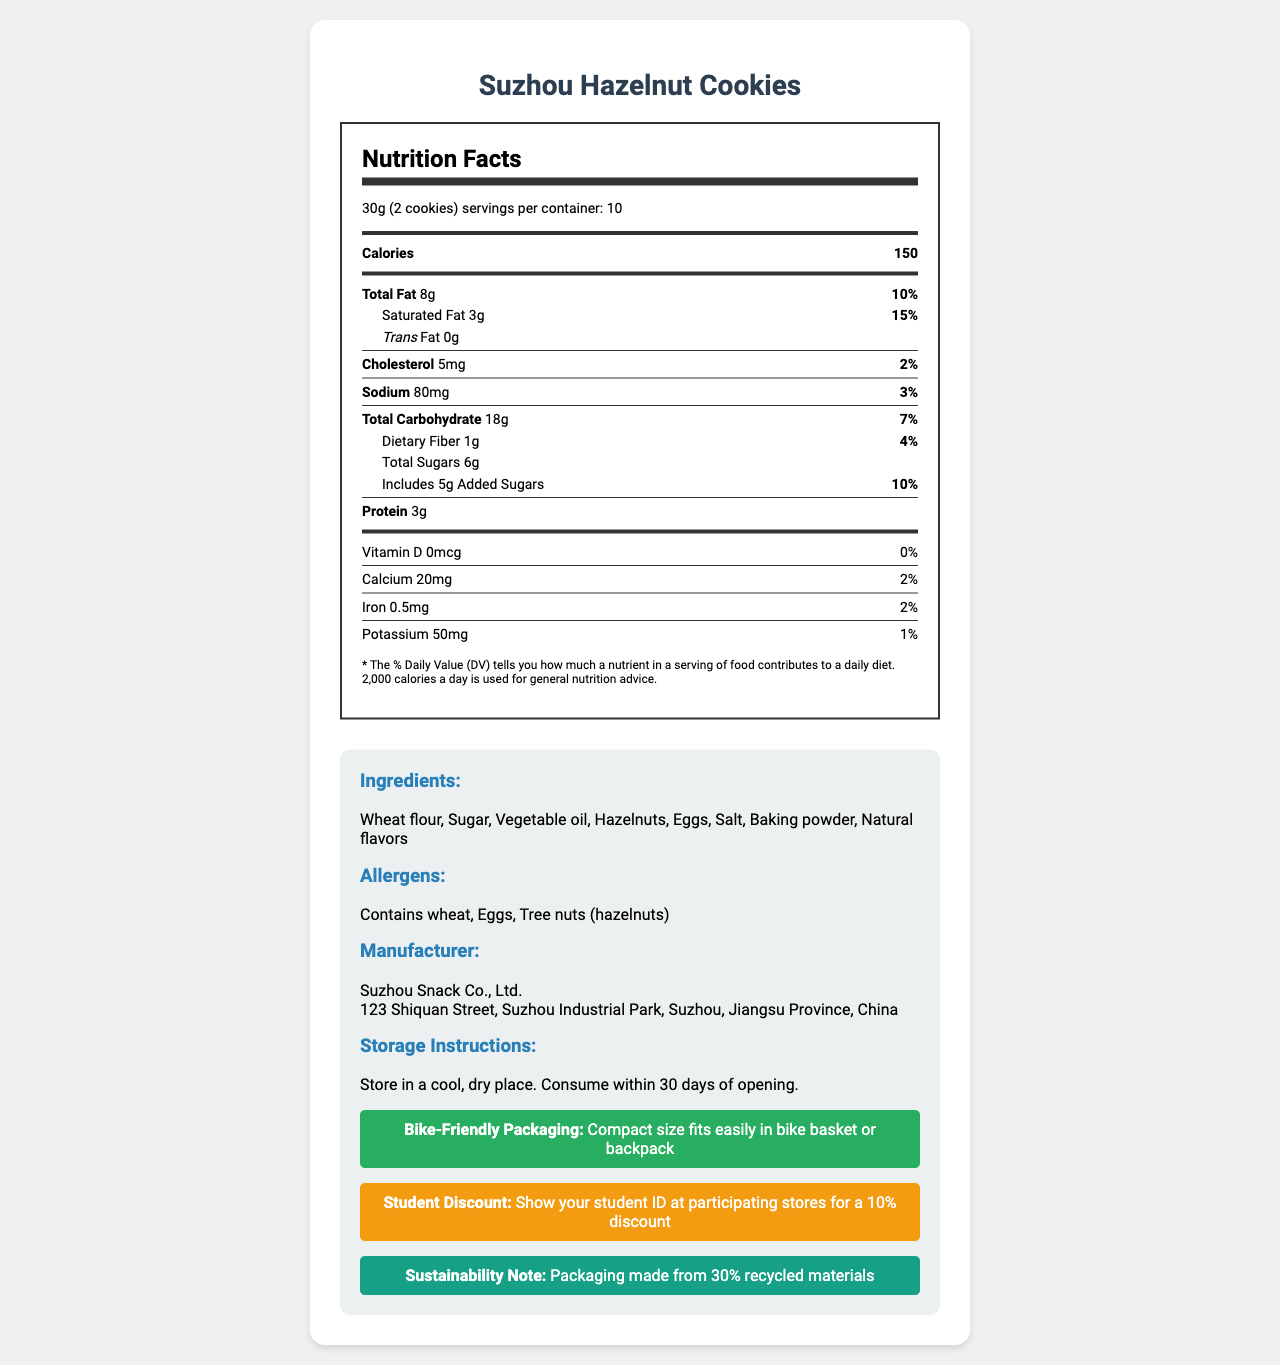what is the serving size of Suzhou Hazelnut Cookies? The serving size is explicitly stated as "30g (2 cookies)" in the document.
Answer: 30g (2 cookies) how many servings are there per container? The document mentions that there are "10" servings per container.
Answer: 10 how many calories are in one serving? The document lists "Calories: 150" for one serving.
Answer: 150 what is the amount of total fat per serving? The amount of total fat per serving is listed as "8g" in the document.
Answer: 8g what daily value percentage does saturated fat represent? The daily value percentage for saturated fat is "15%" as stated in the document.
Answer: 15% how many grams of added sugars are included per serving? The document specifies "5g" of added sugars per serving.
Answer: 5g what allergens are present in Suzhou Hazelnut Cookies? The allergens section lists "Contains wheat, Eggs, Tree nuts (hazelnuts)."
Answer: Wheat, Eggs, Tree nuts (hazelnuts) how much potassium does one serving of Suzhou Hazelnut Cookies contain? The potassium content per serving is documented as "50mg."
Answer: 50mg how many grams of protein are in a serving? The amount of protein per serving is stated as "3g" in the document.
Answer: 3g what is the amount of sodium in each serving? The amount of sodium in each serving is listed as "80mg."
Answer: 80mg which of the following is NOT an ingredient in Suzhou Hazelnut Cookies? 1. Sugar 2. Hazelnuts 3. Soy 4. Baking powder The ingredients listed are Wheat flour, Sugar, Vegetable oil, Hazelnuts, Eggs, Salt, Baking powder, Natural flavors. Soy is not mentioned.
Answer: 3. Soy what is the daily value percentage of cholesterol? 1. 1% 2. 2% 3. 3% 4. 5% The daily value percentage for cholesterol is "2%" as mentioned in the document.
Answer: 2. 2% does the document state the storage instructions? The document includes storage instructions that say "Store in a cool, dry place. Consume within 30 days of opening."
Answer: Yes do these cookies contain any trans fat? The document states that trans fat content is "0g."
Answer: No what is the main idea of the document? The document includes information on serving size, calories, fats, cholesterol, sodium, carbohydrates, sugars, protein, vitamins, minerals, ingredients, allergens, manufacturer details, storage instructions, packaging, student discount, and sustainability.
Answer: The main idea of the document is to provide detailed nutritional information, ingredients, allergens, and additional notes on Suzhou Hazelnut Cookies. can the manufacturer provide more information about the recipe? The document does not mention whether the manufacturer can provide more information about the recipe. The focus is on nutritional facts and general product information.
Answer: Not enough information 